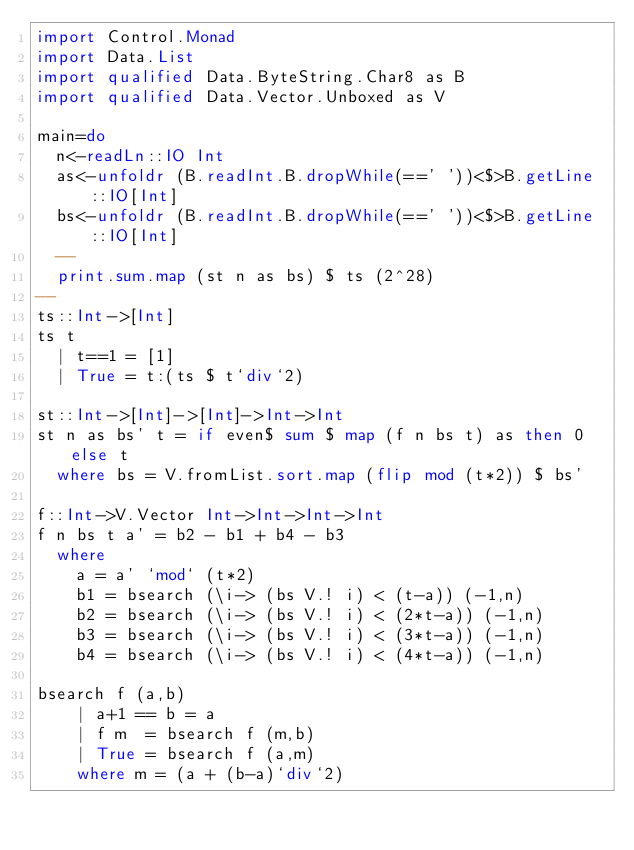<code> <loc_0><loc_0><loc_500><loc_500><_Haskell_>import Control.Monad
import Data.List
import qualified Data.ByteString.Char8 as B
import qualified Data.Vector.Unboxed as V

main=do
  n<-readLn::IO Int
  as<-unfoldr (B.readInt.B.dropWhile(==' '))<$>B.getLine::IO[Int]
  bs<-unfoldr (B.readInt.B.dropWhile(==' '))<$>B.getLine::IO[Int]
  --
  print.sum.map (st n as bs) $ ts (2^28)
--
ts::Int->[Int]
ts t
  | t==1 = [1]
  | True = t:(ts $ t`div`2)

st::Int->[Int]->[Int]->Int->Int
st n as bs' t = if even$ sum $ map (f n bs t) as then 0 else t
  where bs = V.fromList.sort.map (flip mod (t*2)) $ bs'

f::Int->V.Vector Int->Int->Int->Int
f n bs t a' = b2 - b1 + b4 - b3
  where
    a = a' `mod` (t*2)
    b1 = bsearch (\i-> (bs V.! i) < (t-a)) (-1,n)
    b2 = bsearch (\i-> (bs V.! i) < (2*t-a)) (-1,n)
    b3 = bsearch (\i-> (bs V.! i) < (3*t-a)) (-1,n)
    b4 = bsearch (\i-> (bs V.! i) < (4*t-a)) (-1,n)

bsearch f (a,b)
    | a+1 == b = a
    | f m  = bsearch f (m,b)
    | True = bsearch f (a,m)
    where m = (a + (b-a)`div`2)</code> 